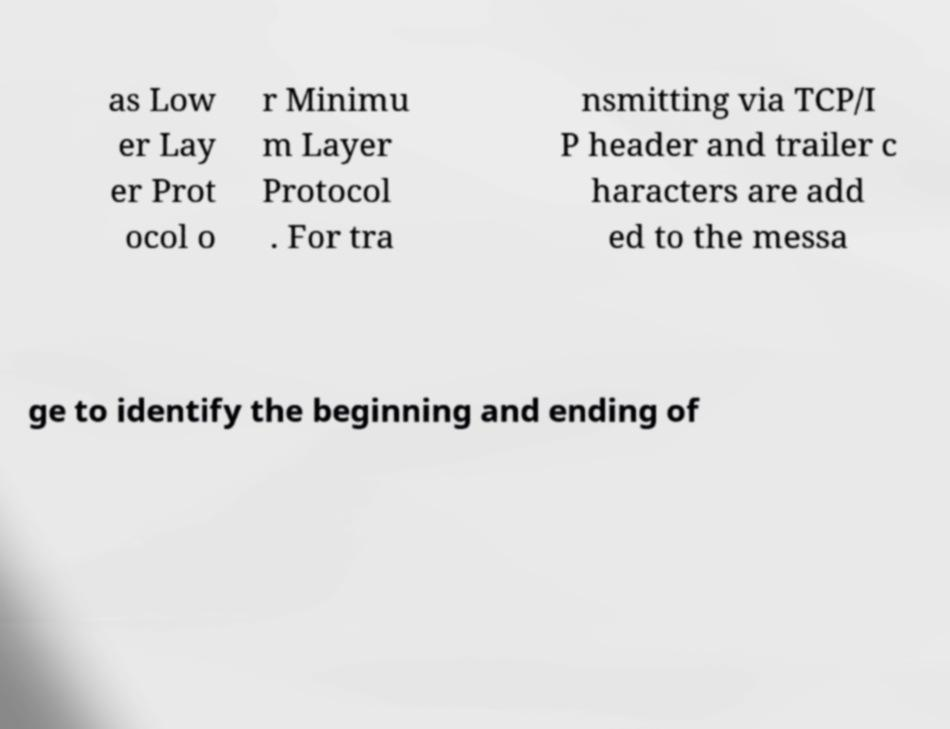Can you read and provide the text displayed in the image?This photo seems to have some interesting text. Can you extract and type it out for me? as Low er Lay er Prot ocol o r Minimu m Layer Protocol . For tra nsmitting via TCP/I P header and trailer c haracters are add ed to the messa ge to identify the beginning and ending of 